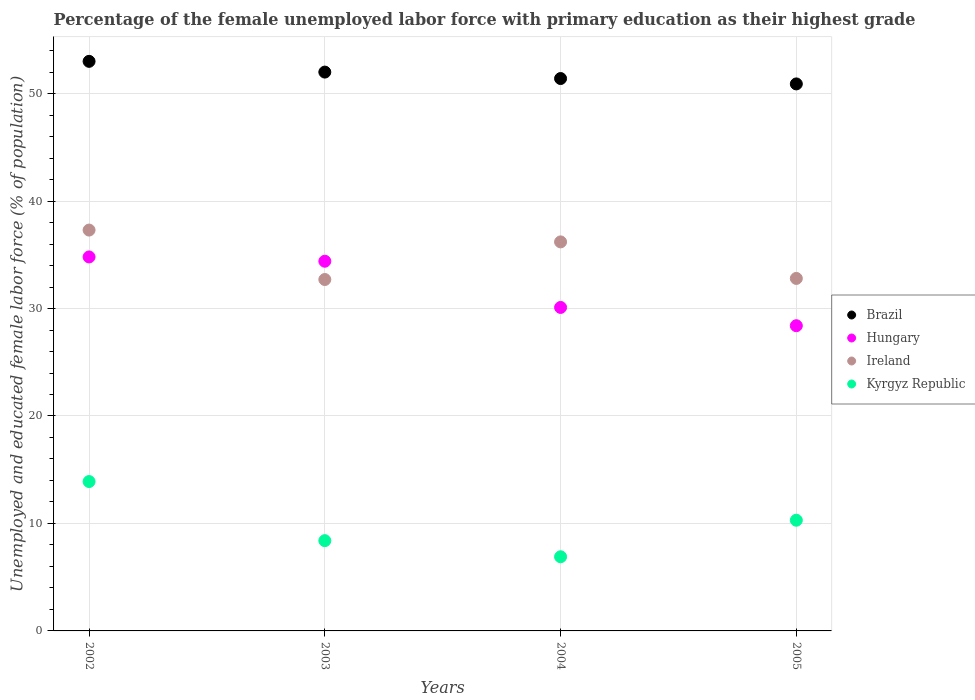How many different coloured dotlines are there?
Your answer should be very brief. 4. Is the number of dotlines equal to the number of legend labels?
Offer a very short reply. Yes. What is the percentage of the unemployed female labor force with primary education in Hungary in 2004?
Provide a succinct answer. 30.1. Across all years, what is the maximum percentage of the unemployed female labor force with primary education in Hungary?
Your answer should be very brief. 34.8. Across all years, what is the minimum percentage of the unemployed female labor force with primary education in Brazil?
Give a very brief answer. 50.9. In which year was the percentage of the unemployed female labor force with primary education in Ireland maximum?
Your answer should be very brief. 2002. In which year was the percentage of the unemployed female labor force with primary education in Ireland minimum?
Provide a succinct answer. 2003. What is the total percentage of the unemployed female labor force with primary education in Hungary in the graph?
Provide a succinct answer. 127.7. What is the difference between the percentage of the unemployed female labor force with primary education in Kyrgyz Republic in 2002 and that in 2004?
Your answer should be compact. 7. What is the difference between the percentage of the unemployed female labor force with primary education in Ireland in 2002 and the percentage of the unemployed female labor force with primary education in Hungary in 2005?
Ensure brevity in your answer.  8.9. What is the average percentage of the unemployed female labor force with primary education in Brazil per year?
Your answer should be compact. 51.83. In the year 2003, what is the difference between the percentage of the unemployed female labor force with primary education in Ireland and percentage of the unemployed female labor force with primary education in Hungary?
Ensure brevity in your answer.  -1.7. In how many years, is the percentage of the unemployed female labor force with primary education in Hungary greater than 42 %?
Provide a succinct answer. 0. What is the ratio of the percentage of the unemployed female labor force with primary education in Ireland in 2003 to that in 2004?
Offer a very short reply. 0.9. Is the difference between the percentage of the unemployed female labor force with primary education in Ireland in 2002 and 2005 greater than the difference between the percentage of the unemployed female labor force with primary education in Hungary in 2002 and 2005?
Offer a terse response. No. What is the difference between the highest and the lowest percentage of the unemployed female labor force with primary education in Hungary?
Provide a succinct answer. 6.4. Is it the case that in every year, the sum of the percentage of the unemployed female labor force with primary education in Kyrgyz Republic and percentage of the unemployed female labor force with primary education in Brazil  is greater than the percentage of the unemployed female labor force with primary education in Ireland?
Offer a terse response. Yes. Is the percentage of the unemployed female labor force with primary education in Hungary strictly greater than the percentage of the unemployed female labor force with primary education in Brazil over the years?
Make the answer very short. No. Is the percentage of the unemployed female labor force with primary education in Ireland strictly less than the percentage of the unemployed female labor force with primary education in Brazil over the years?
Your answer should be very brief. Yes. How many dotlines are there?
Your answer should be compact. 4. How many years are there in the graph?
Keep it short and to the point. 4. Are the values on the major ticks of Y-axis written in scientific E-notation?
Provide a succinct answer. No. Does the graph contain any zero values?
Offer a terse response. No. How many legend labels are there?
Make the answer very short. 4. What is the title of the graph?
Your answer should be very brief. Percentage of the female unemployed labor force with primary education as their highest grade. Does "Kazakhstan" appear as one of the legend labels in the graph?
Your answer should be very brief. No. What is the label or title of the Y-axis?
Your answer should be very brief. Unemployed and educated female labor force (% of population). What is the Unemployed and educated female labor force (% of population) of Brazil in 2002?
Ensure brevity in your answer.  53. What is the Unemployed and educated female labor force (% of population) of Hungary in 2002?
Offer a terse response. 34.8. What is the Unemployed and educated female labor force (% of population) of Ireland in 2002?
Offer a terse response. 37.3. What is the Unemployed and educated female labor force (% of population) of Kyrgyz Republic in 2002?
Offer a very short reply. 13.9. What is the Unemployed and educated female labor force (% of population) in Brazil in 2003?
Give a very brief answer. 52. What is the Unemployed and educated female labor force (% of population) in Hungary in 2003?
Give a very brief answer. 34.4. What is the Unemployed and educated female labor force (% of population) in Ireland in 2003?
Your answer should be very brief. 32.7. What is the Unemployed and educated female labor force (% of population) in Kyrgyz Republic in 2003?
Ensure brevity in your answer.  8.4. What is the Unemployed and educated female labor force (% of population) of Brazil in 2004?
Keep it short and to the point. 51.4. What is the Unemployed and educated female labor force (% of population) in Hungary in 2004?
Your response must be concise. 30.1. What is the Unemployed and educated female labor force (% of population) in Ireland in 2004?
Ensure brevity in your answer.  36.2. What is the Unemployed and educated female labor force (% of population) in Kyrgyz Republic in 2004?
Provide a short and direct response. 6.9. What is the Unemployed and educated female labor force (% of population) of Brazil in 2005?
Provide a short and direct response. 50.9. What is the Unemployed and educated female labor force (% of population) of Hungary in 2005?
Keep it short and to the point. 28.4. What is the Unemployed and educated female labor force (% of population) of Ireland in 2005?
Your response must be concise. 32.8. What is the Unemployed and educated female labor force (% of population) in Kyrgyz Republic in 2005?
Your answer should be compact. 10.3. Across all years, what is the maximum Unemployed and educated female labor force (% of population) of Hungary?
Provide a short and direct response. 34.8. Across all years, what is the maximum Unemployed and educated female labor force (% of population) in Ireland?
Your response must be concise. 37.3. Across all years, what is the maximum Unemployed and educated female labor force (% of population) in Kyrgyz Republic?
Provide a short and direct response. 13.9. Across all years, what is the minimum Unemployed and educated female labor force (% of population) of Brazil?
Provide a succinct answer. 50.9. Across all years, what is the minimum Unemployed and educated female labor force (% of population) of Hungary?
Your response must be concise. 28.4. Across all years, what is the minimum Unemployed and educated female labor force (% of population) of Ireland?
Provide a succinct answer. 32.7. Across all years, what is the minimum Unemployed and educated female labor force (% of population) of Kyrgyz Republic?
Your answer should be very brief. 6.9. What is the total Unemployed and educated female labor force (% of population) of Brazil in the graph?
Provide a succinct answer. 207.3. What is the total Unemployed and educated female labor force (% of population) in Hungary in the graph?
Provide a succinct answer. 127.7. What is the total Unemployed and educated female labor force (% of population) of Ireland in the graph?
Offer a terse response. 139. What is the total Unemployed and educated female labor force (% of population) in Kyrgyz Republic in the graph?
Your response must be concise. 39.5. What is the difference between the Unemployed and educated female labor force (% of population) of Ireland in 2002 and that in 2003?
Provide a short and direct response. 4.6. What is the difference between the Unemployed and educated female labor force (% of population) in Kyrgyz Republic in 2002 and that in 2003?
Provide a short and direct response. 5.5. What is the difference between the Unemployed and educated female labor force (% of population) in Brazil in 2002 and that in 2004?
Keep it short and to the point. 1.6. What is the difference between the Unemployed and educated female labor force (% of population) of Ireland in 2002 and that in 2004?
Your answer should be compact. 1.1. What is the difference between the Unemployed and educated female labor force (% of population) of Kyrgyz Republic in 2002 and that in 2004?
Your response must be concise. 7. What is the difference between the Unemployed and educated female labor force (% of population) in Ireland in 2002 and that in 2005?
Offer a very short reply. 4.5. What is the difference between the Unemployed and educated female labor force (% of population) of Brazil in 2003 and that in 2004?
Your answer should be compact. 0.6. What is the difference between the Unemployed and educated female labor force (% of population) in Ireland in 2003 and that in 2004?
Keep it short and to the point. -3.5. What is the difference between the Unemployed and educated female labor force (% of population) of Brazil in 2003 and that in 2005?
Offer a terse response. 1.1. What is the difference between the Unemployed and educated female labor force (% of population) in Hungary in 2003 and that in 2005?
Your answer should be very brief. 6. What is the difference between the Unemployed and educated female labor force (% of population) in Kyrgyz Republic in 2003 and that in 2005?
Provide a short and direct response. -1.9. What is the difference between the Unemployed and educated female labor force (% of population) of Brazil in 2004 and that in 2005?
Provide a succinct answer. 0.5. What is the difference between the Unemployed and educated female labor force (% of population) in Ireland in 2004 and that in 2005?
Your answer should be compact. 3.4. What is the difference between the Unemployed and educated female labor force (% of population) in Kyrgyz Republic in 2004 and that in 2005?
Offer a terse response. -3.4. What is the difference between the Unemployed and educated female labor force (% of population) of Brazil in 2002 and the Unemployed and educated female labor force (% of population) of Hungary in 2003?
Make the answer very short. 18.6. What is the difference between the Unemployed and educated female labor force (% of population) in Brazil in 2002 and the Unemployed and educated female labor force (% of population) in Ireland in 2003?
Provide a short and direct response. 20.3. What is the difference between the Unemployed and educated female labor force (% of population) of Brazil in 2002 and the Unemployed and educated female labor force (% of population) of Kyrgyz Republic in 2003?
Make the answer very short. 44.6. What is the difference between the Unemployed and educated female labor force (% of population) in Hungary in 2002 and the Unemployed and educated female labor force (% of population) in Ireland in 2003?
Offer a very short reply. 2.1. What is the difference between the Unemployed and educated female labor force (% of population) of Hungary in 2002 and the Unemployed and educated female labor force (% of population) of Kyrgyz Republic in 2003?
Your answer should be very brief. 26.4. What is the difference between the Unemployed and educated female labor force (% of population) in Ireland in 2002 and the Unemployed and educated female labor force (% of population) in Kyrgyz Republic in 2003?
Provide a succinct answer. 28.9. What is the difference between the Unemployed and educated female labor force (% of population) in Brazil in 2002 and the Unemployed and educated female labor force (% of population) in Hungary in 2004?
Your answer should be very brief. 22.9. What is the difference between the Unemployed and educated female labor force (% of population) of Brazil in 2002 and the Unemployed and educated female labor force (% of population) of Ireland in 2004?
Offer a terse response. 16.8. What is the difference between the Unemployed and educated female labor force (% of population) in Brazil in 2002 and the Unemployed and educated female labor force (% of population) in Kyrgyz Republic in 2004?
Offer a terse response. 46.1. What is the difference between the Unemployed and educated female labor force (% of population) of Hungary in 2002 and the Unemployed and educated female labor force (% of population) of Ireland in 2004?
Your answer should be very brief. -1.4. What is the difference between the Unemployed and educated female labor force (% of population) in Hungary in 2002 and the Unemployed and educated female labor force (% of population) in Kyrgyz Republic in 2004?
Your answer should be very brief. 27.9. What is the difference between the Unemployed and educated female labor force (% of population) in Ireland in 2002 and the Unemployed and educated female labor force (% of population) in Kyrgyz Republic in 2004?
Make the answer very short. 30.4. What is the difference between the Unemployed and educated female labor force (% of population) of Brazil in 2002 and the Unemployed and educated female labor force (% of population) of Hungary in 2005?
Give a very brief answer. 24.6. What is the difference between the Unemployed and educated female labor force (% of population) of Brazil in 2002 and the Unemployed and educated female labor force (% of population) of Ireland in 2005?
Ensure brevity in your answer.  20.2. What is the difference between the Unemployed and educated female labor force (% of population) of Brazil in 2002 and the Unemployed and educated female labor force (% of population) of Kyrgyz Republic in 2005?
Ensure brevity in your answer.  42.7. What is the difference between the Unemployed and educated female labor force (% of population) of Brazil in 2003 and the Unemployed and educated female labor force (% of population) of Hungary in 2004?
Make the answer very short. 21.9. What is the difference between the Unemployed and educated female labor force (% of population) of Brazil in 2003 and the Unemployed and educated female labor force (% of population) of Ireland in 2004?
Your response must be concise. 15.8. What is the difference between the Unemployed and educated female labor force (% of population) of Brazil in 2003 and the Unemployed and educated female labor force (% of population) of Kyrgyz Republic in 2004?
Keep it short and to the point. 45.1. What is the difference between the Unemployed and educated female labor force (% of population) of Ireland in 2003 and the Unemployed and educated female labor force (% of population) of Kyrgyz Republic in 2004?
Keep it short and to the point. 25.8. What is the difference between the Unemployed and educated female labor force (% of population) of Brazil in 2003 and the Unemployed and educated female labor force (% of population) of Hungary in 2005?
Give a very brief answer. 23.6. What is the difference between the Unemployed and educated female labor force (% of population) of Brazil in 2003 and the Unemployed and educated female labor force (% of population) of Kyrgyz Republic in 2005?
Offer a very short reply. 41.7. What is the difference between the Unemployed and educated female labor force (% of population) in Hungary in 2003 and the Unemployed and educated female labor force (% of population) in Kyrgyz Republic in 2005?
Offer a very short reply. 24.1. What is the difference between the Unemployed and educated female labor force (% of population) in Ireland in 2003 and the Unemployed and educated female labor force (% of population) in Kyrgyz Republic in 2005?
Provide a succinct answer. 22.4. What is the difference between the Unemployed and educated female labor force (% of population) of Brazil in 2004 and the Unemployed and educated female labor force (% of population) of Hungary in 2005?
Provide a succinct answer. 23. What is the difference between the Unemployed and educated female labor force (% of population) in Brazil in 2004 and the Unemployed and educated female labor force (% of population) in Kyrgyz Republic in 2005?
Your response must be concise. 41.1. What is the difference between the Unemployed and educated female labor force (% of population) in Hungary in 2004 and the Unemployed and educated female labor force (% of population) in Kyrgyz Republic in 2005?
Offer a very short reply. 19.8. What is the difference between the Unemployed and educated female labor force (% of population) of Ireland in 2004 and the Unemployed and educated female labor force (% of population) of Kyrgyz Republic in 2005?
Make the answer very short. 25.9. What is the average Unemployed and educated female labor force (% of population) in Brazil per year?
Offer a very short reply. 51.83. What is the average Unemployed and educated female labor force (% of population) in Hungary per year?
Provide a succinct answer. 31.93. What is the average Unemployed and educated female labor force (% of population) of Ireland per year?
Keep it short and to the point. 34.75. What is the average Unemployed and educated female labor force (% of population) of Kyrgyz Republic per year?
Keep it short and to the point. 9.88. In the year 2002, what is the difference between the Unemployed and educated female labor force (% of population) in Brazil and Unemployed and educated female labor force (% of population) in Ireland?
Provide a short and direct response. 15.7. In the year 2002, what is the difference between the Unemployed and educated female labor force (% of population) of Brazil and Unemployed and educated female labor force (% of population) of Kyrgyz Republic?
Ensure brevity in your answer.  39.1. In the year 2002, what is the difference between the Unemployed and educated female labor force (% of population) of Hungary and Unemployed and educated female labor force (% of population) of Ireland?
Offer a very short reply. -2.5. In the year 2002, what is the difference between the Unemployed and educated female labor force (% of population) in Hungary and Unemployed and educated female labor force (% of population) in Kyrgyz Republic?
Make the answer very short. 20.9. In the year 2002, what is the difference between the Unemployed and educated female labor force (% of population) in Ireland and Unemployed and educated female labor force (% of population) in Kyrgyz Republic?
Make the answer very short. 23.4. In the year 2003, what is the difference between the Unemployed and educated female labor force (% of population) in Brazil and Unemployed and educated female labor force (% of population) in Ireland?
Ensure brevity in your answer.  19.3. In the year 2003, what is the difference between the Unemployed and educated female labor force (% of population) in Brazil and Unemployed and educated female labor force (% of population) in Kyrgyz Republic?
Provide a succinct answer. 43.6. In the year 2003, what is the difference between the Unemployed and educated female labor force (% of population) in Hungary and Unemployed and educated female labor force (% of population) in Ireland?
Ensure brevity in your answer.  1.7. In the year 2003, what is the difference between the Unemployed and educated female labor force (% of population) in Ireland and Unemployed and educated female labor force (% of population) in Kyrgyz Republic?
Give a very brief answer. 24.3. In the year 2004, what is the difference between the Unemployed and educated female labor force (% of population) of Brazil and Unemployed and educated female labor force (% of population) of Hungary?
Keep it short and to the point. 21.3. In the year 2004, what is the difference between the Unemployed and educated female labor force (% of population) in Brazil and Unemployed and educated female labor force (% of population) in Ireland?
Make the answer very short. 15.2. In the year 2004, what is the difference between the Unemployed and educated female labor force (% of population) in Brazil and Unemployed and educated female labor force (% of population) in Kyrgyz Republic?
Your response must be concise. 44.5. In the year 2004, what is the difference between the Unemployed and educated female labor force (% of population) in Hungary and Unemployed and educated female labor force (% of population) in Kyrgyz Republic?
Offer a terse response. 23.2. In the year 2004, what is the difference between the Unemployed and educated female labor force (% of population) of Ireland and Unemployed and educated female labor force (% of population) of Kyrgyz Republic?
Ensure brevity in your answer.  29.3. In the year 2005, what is the difference between the Unemployed and educated female labor force (% of population) in Brazil and Unemployed and educated female labor force (% of population) in Hungary?
Make the answer very short. 22.5. In the year 2005, what is the difference between the Unemployed and educated female labor force (% of population) of Brazil and Unemployed and educated female labor force (% of population) of Ireland?
Your answer should be very brief. 18.1. In the year 2005, what is the difference between the Unemployed and educated female labor force (% of population) of Brazil and Unemployed and educated female labor force (% of population) of Kyrgyz Republic?
Offer a terse response. 40.6. In the year 2005, what is the difference between the Unemployed and educated female labor force (% of population) of Hungary and Unemployed and educated female labor force (% of population) of Kyrgyz Republic?
Offer a terse response. 18.1. In the year 2005, what is the difference between the Unemployed and educated female labor force (% of population) in Ireland and Unemployed and educated female labor force (% of population) in Kyrgyz Republic?
Provide a short and direct response. 22.5. What is the ratio of the Unemployed and educated female labor force (% of population) in Brazil in 2002 to that in 2003?
Offer a terse response. 1.02. What is the ratio of the Unemployed and educated female labor force (% of population) of Hungary in 2002 to that in 2003?
Offer a terse response. 1.01. What is the ratio of the Unemployed and educated female labor force (% of population) in Ireland in 2002 to that in 2003?
Provide a short and direct response. 1.14. What is the ratio of the Unemployed and educated female labor force (% of population) of Kyrgyz Republic in 2002 to that in 2003?
Provide a succinct answer. 1.65. What is the ratio of the Unemployed and educated female labor force (% of population) of Brazil in 2002 to that in 2004?
Your answer should be compact. 1.03. What is the ratio of the Unemployed and educated female labor force (% of population) of Hungary in 2002 to that in 2004?
Offer a very short reply. 1.16. What is the ratio of the Unemployed and educated female labor force (% of population) of Ireland in 2002 to that in 2004?
Keep it short and to the point. 1.03. What is the ratio of the Unemployed and educated female labor force (% of population) in Kyrgyz Republic in 2002 to that in 2004?
Provide a succinct answer. 2.01. What is the ratio of the Unemployed and educated female labor force (% of population) of Brazil in 2002 to that in 2005?
Make the answer very short. 1.04. What is the ratio of the Unemployed and educated female labor force (% of population) of Hungary in 2002 to that in 2005?
Your answer should be compact. 1.23. What is the ratio of the Unemployed and educated female labor force (% of population) of Ireland in 2002 to that in 2005?
Provide a short and direct response. 1.14. What is the ratio of the Unemployed and educated female labor force (% of population) in Kyrgyz Republic in 2002 to that in 2005?
Your response must be concise. 1.35. What is the ratio of the Unemployed and educated female labor force (% of population) of Brazil in 2003 to that in 2004?
Your answer should be very brief. 1.01. What is the ratio of the Unemployed and educated female labor force (% of population) in Hungary in 2003 to that in 2004?
Your answer should be very brief. 1.14. What is the ratio of the Unemployed and educated female labor force (% of population) of Ireland in 2003 to that in 2004?
Provide a succinct answer. 0.9. What is the ratio of the Unemployed and educated female labor force (% of population) of Kyrgyz Republic in 2003 to that in 2004?
Give a very brief answer. 1.22. What is the ratio of the Unemployed and educated female labor force (% of population) in Brazil in 2003 to that in 2005?
Give a very brief answer. 1.02. What is the ratio of the Unemployed and educated female labor force (% of population) in Hungary in 2003 to that in 2005?
Keep it short and to the point. 1.21. What is the ratio of the Unemployed and educated female labor force (% of population) in Ireland in 2003 to that in 2005?
Ensure brevity in your answer.  1. What is the ratio of the Unemployed and educated female labor force (% of population) of Kyrgyz Republic in 2003 to that in 2005?
Keep it short and to the point. 0.82. What is the ratio of the Unemployed and educated female labor force (% of population) of Brazil in 2004 to that in 2005?
Provide a succinct answer. 1.01. What is the ratio of the Unemployed and educated female labor force (% of population) in Hungary in 2004 to that in 2005?
Provide a succinct answer. 1.06. What is the ratio of the Unemployed and educated female labor force (% of population) of Ireland in 2004 to that in 2005?
Provide a succinct answer. 1.1. What is the ratio of the Unemployed and educated female labor force (% of population) of Kyrgyz Republic in 2004 to that in 2005?
Provide a short and direct response. 0.67. What is the difference between the highest and the second highest Unemployed and educated female labor force (% of population) of Kyrgyz Republic?
Your answer should be compact. 3.6. What is the difference between the highest and the lowest Unemployed and educated female labor force (% of population) in Ireland?
Offer a terse response. 4.6. What is the difference between the highest and the lowest Unemployed and educated female labor force (% of population) of Kyrgyz Republic?
Offer a very short reply. 7. 